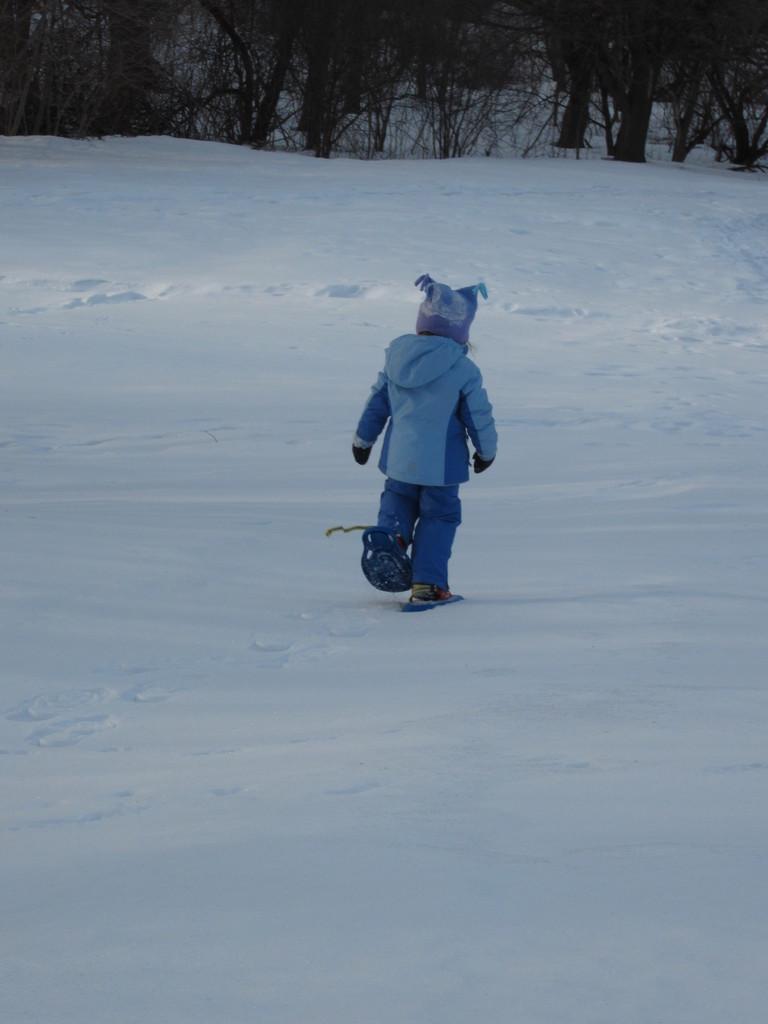In one or two sentences, can you explain what this image depicts? In this image I can see the person standing on the snow and the person is wearing blue color dress. In the background I can see few trees. 